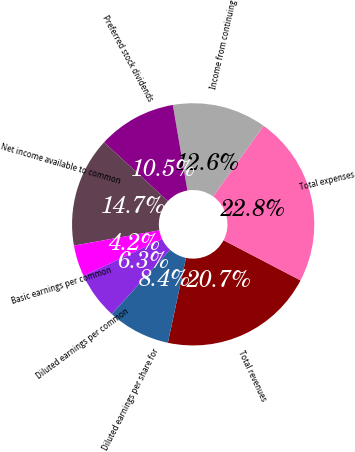Convert chart. <chart><loc_0><loc_0><loc_500><loc_500><pie_chart><fcel>Total revenues<fcel>Total expenses<fcel>Income from continuing<fcel>Preferred stock dividends<fcel>Net income available to common<fcel>Basic earnings per common<fcel>Diluted earnings per common<fcel>Diluted earnings per share for<nl><fcel>20.69%<fcel>22.78%<fcel>12.56%<fcel>10.47%<fcel>14.65%<fcel>4.19%<fcel>6.28%<fcel>8.37%<nl></chart> 